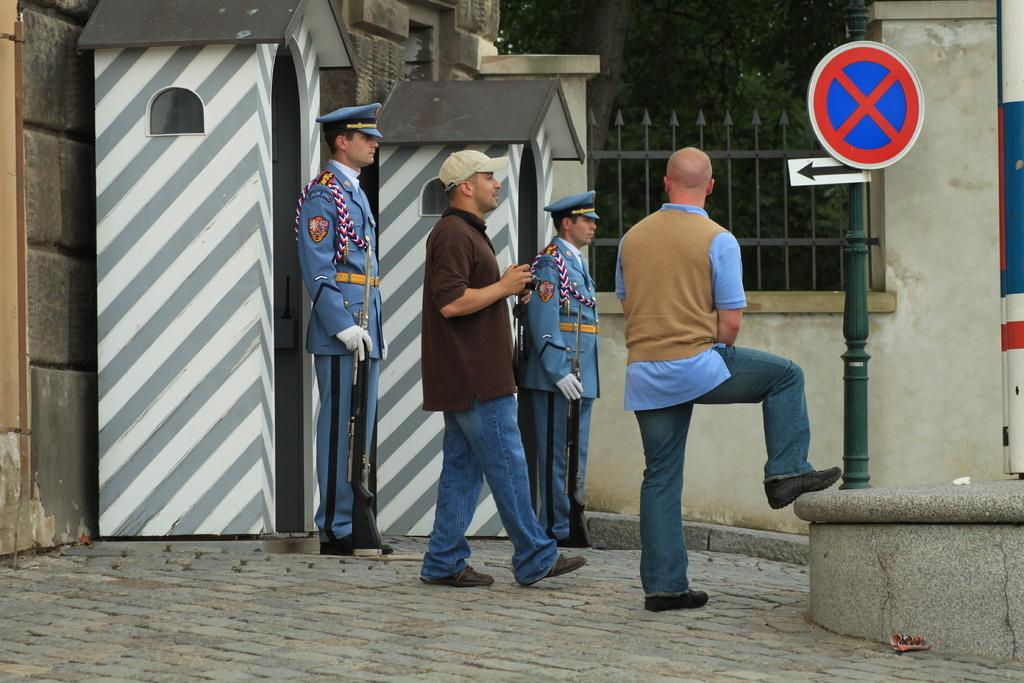How many men are present in the image? There are four men standing in the foreground of the image. What is the surface on which the men are standing? The men are standing on the ground. What can be seen in the image besides the men? There is a sign board, railing, two cardboard huts, a wall, and a tree in the image. What type of waste can be seen in the image? There is no waste visible in the image. Is there a turkey present in the image? No, there is no turkey present in the image. 